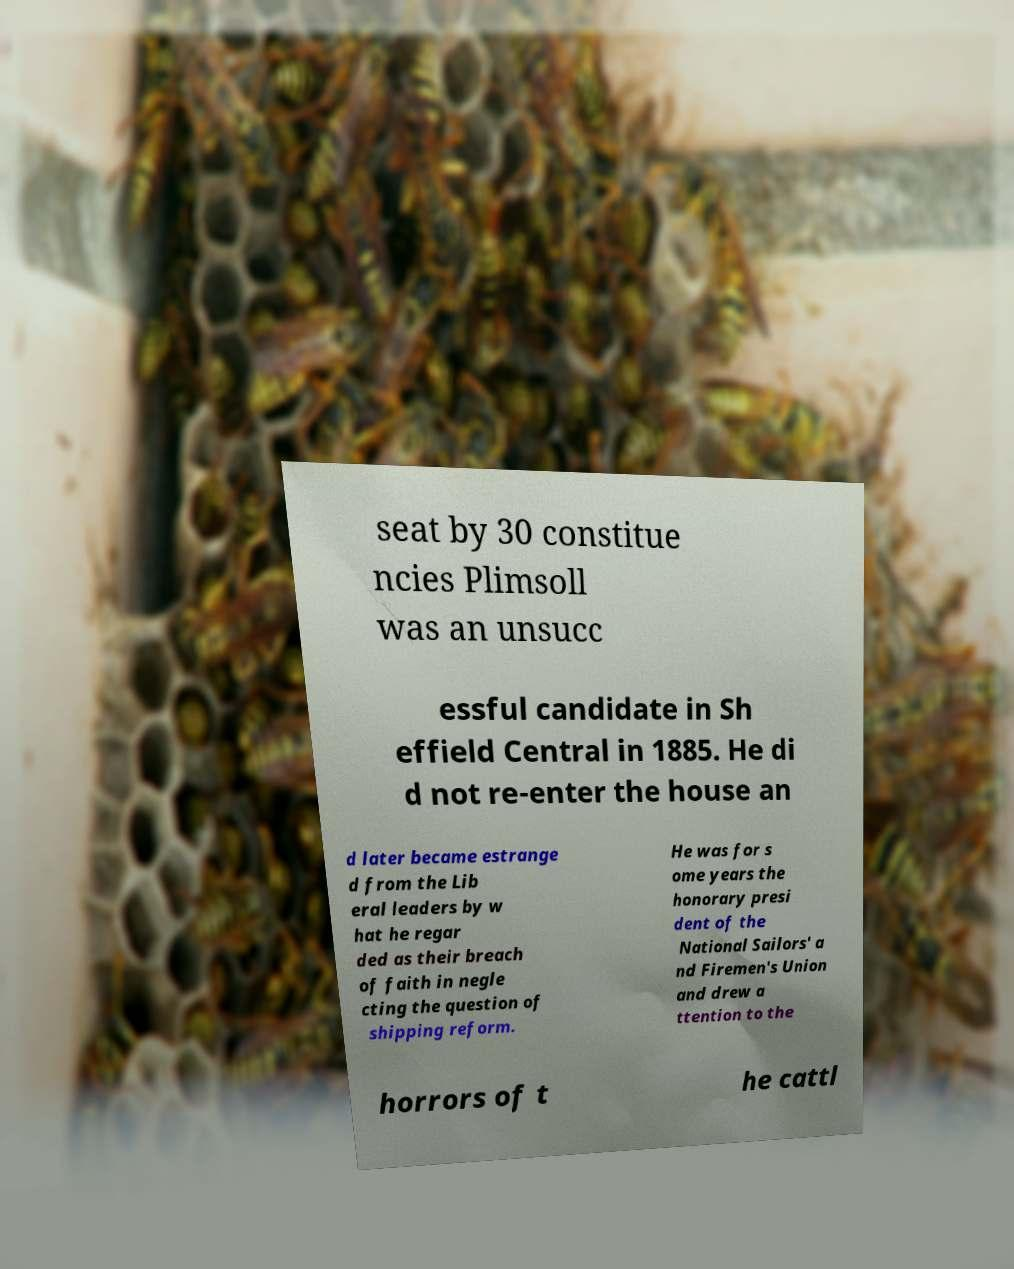Please read and relay the text visible in this image. What does it say? seat by 30 constitue ncies Plimsoll was an unsucc essful candidate in Sh effield Central in 1885. He di d not re-enter the house an d later became estrange d from the Lib eral leaders by w hat he regar ded as their breach of faith in negle cting the question of shipping reform. He was for s ome years the honorary presi dent of the National Sailors' a nd Firemen's Union and drew a ttention to the horrors of t he cattl 